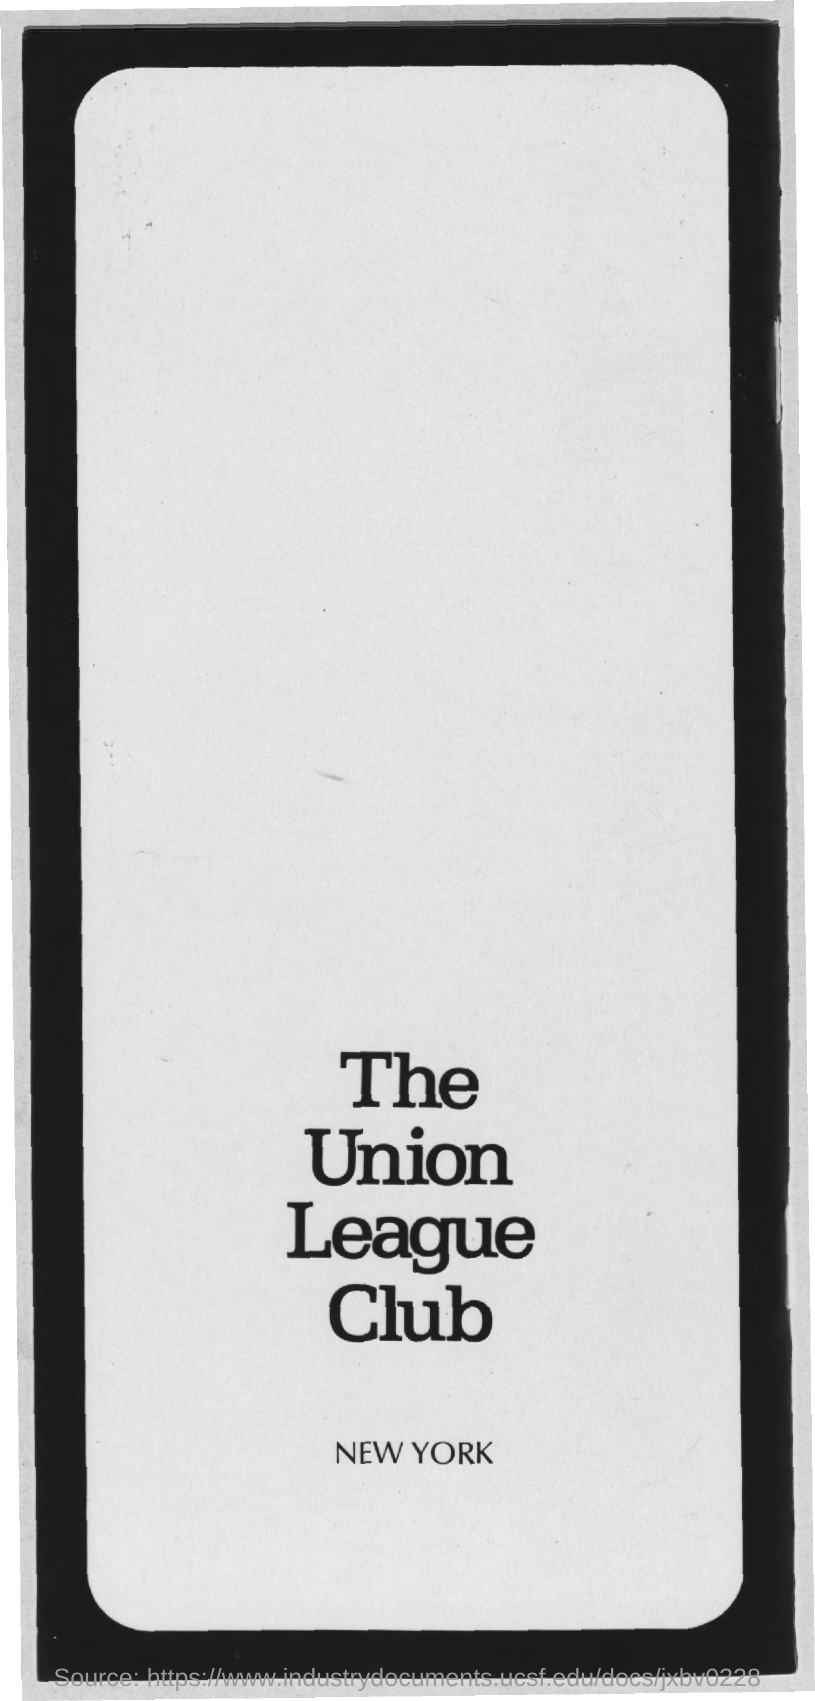What is the title of the document?
Your response must be concise. The union league club. What is the name of the place mentioned in the document?
Your response must be concise. New York. 